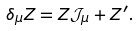<formula> <loc_0><loc_0><loc_500><loc_500>\delta _ { \mu } Z = Z \mathcal { J } _ { \mu } + Z ^ { \prime } .</formula> 